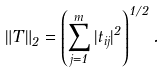<formula> <loc_0><loc_0><loc_500><loc_500>\| T \| _ { 2 } = \left ( \sum _ { j = 1 } ^ { m } | t _ { i j } | ^ { 2 } \right ) ^ { 1 / 2 } .</formula> 